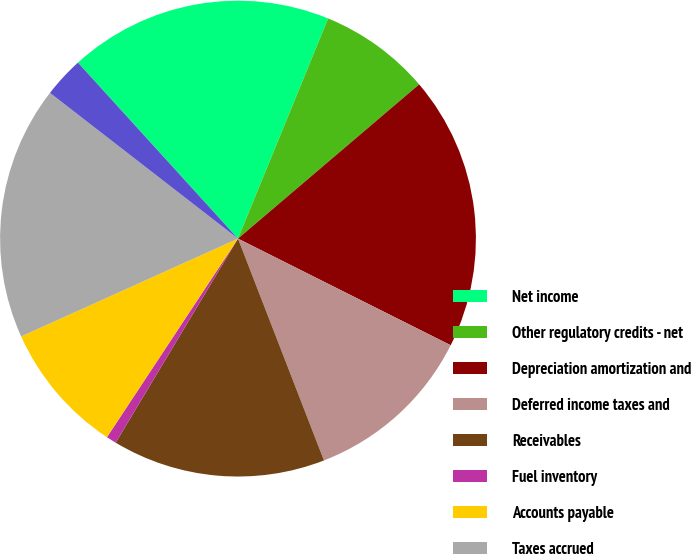Convert chart. <chart><loc_0><loc_0><loc_500><loc_500><pie_chart><fcel>Net income<fcel>Other regulatory credits - net<fcel>Depreciation amortization and<fcel>Deferred income taxes and<fcel>Receivables<fcel>Fuel inventory<fcel>Accounts payable<fcel>Taxes accrued<fcel>Interest accrued<fcel>Deferred fuel costs<nl><fcel>17.93%<fcel>7.59%<fcel>18.62%<fcel>11.72%<fcel>14.48%<fcel>0.69%<fcel>8.97%<fcel>17.24%<fcel>0.0%<fcel>2.76%<nl></chart> 